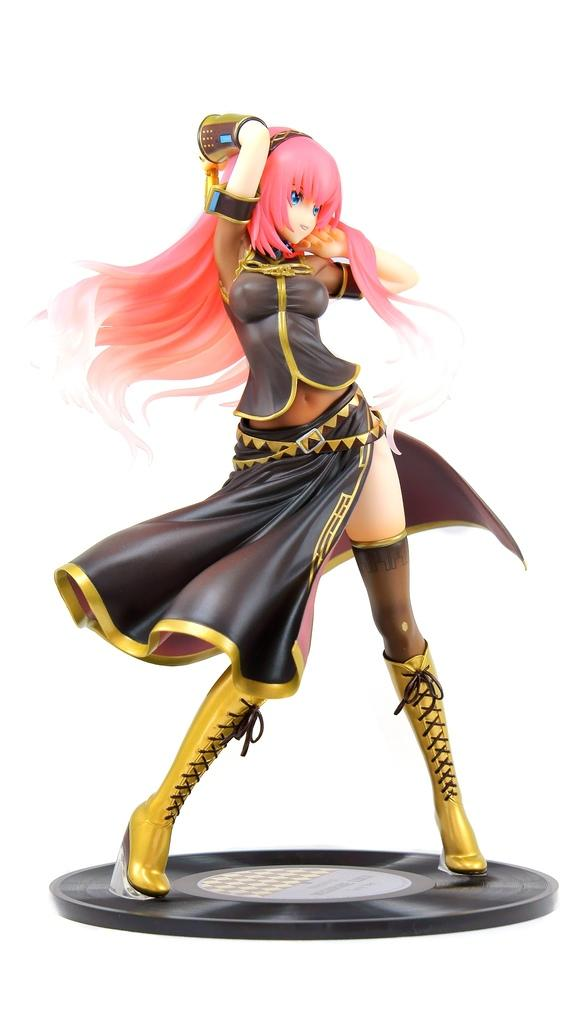What is present in the picture? There is a doll present in the picture. Where is the doll's toothbrush located in the image? There is no toothbrush present in the image, as it only features a doll. 